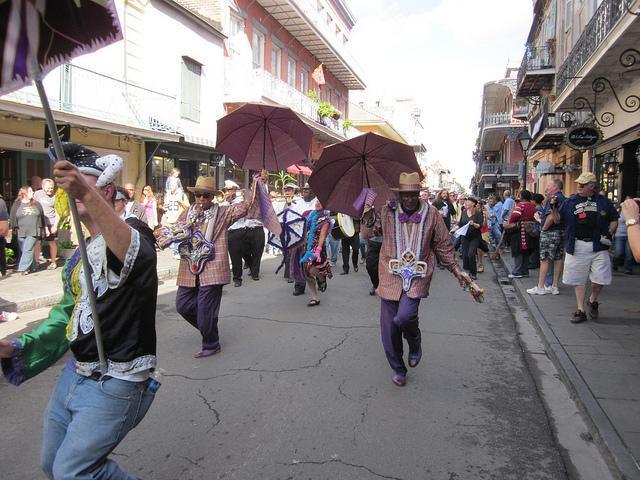How many umbrellas are there?
Give a very brief answer. 3. How many people are there?
Give a very brief answer. 8. How many donuts are in the last row?
Give a very brief answer. 0. 